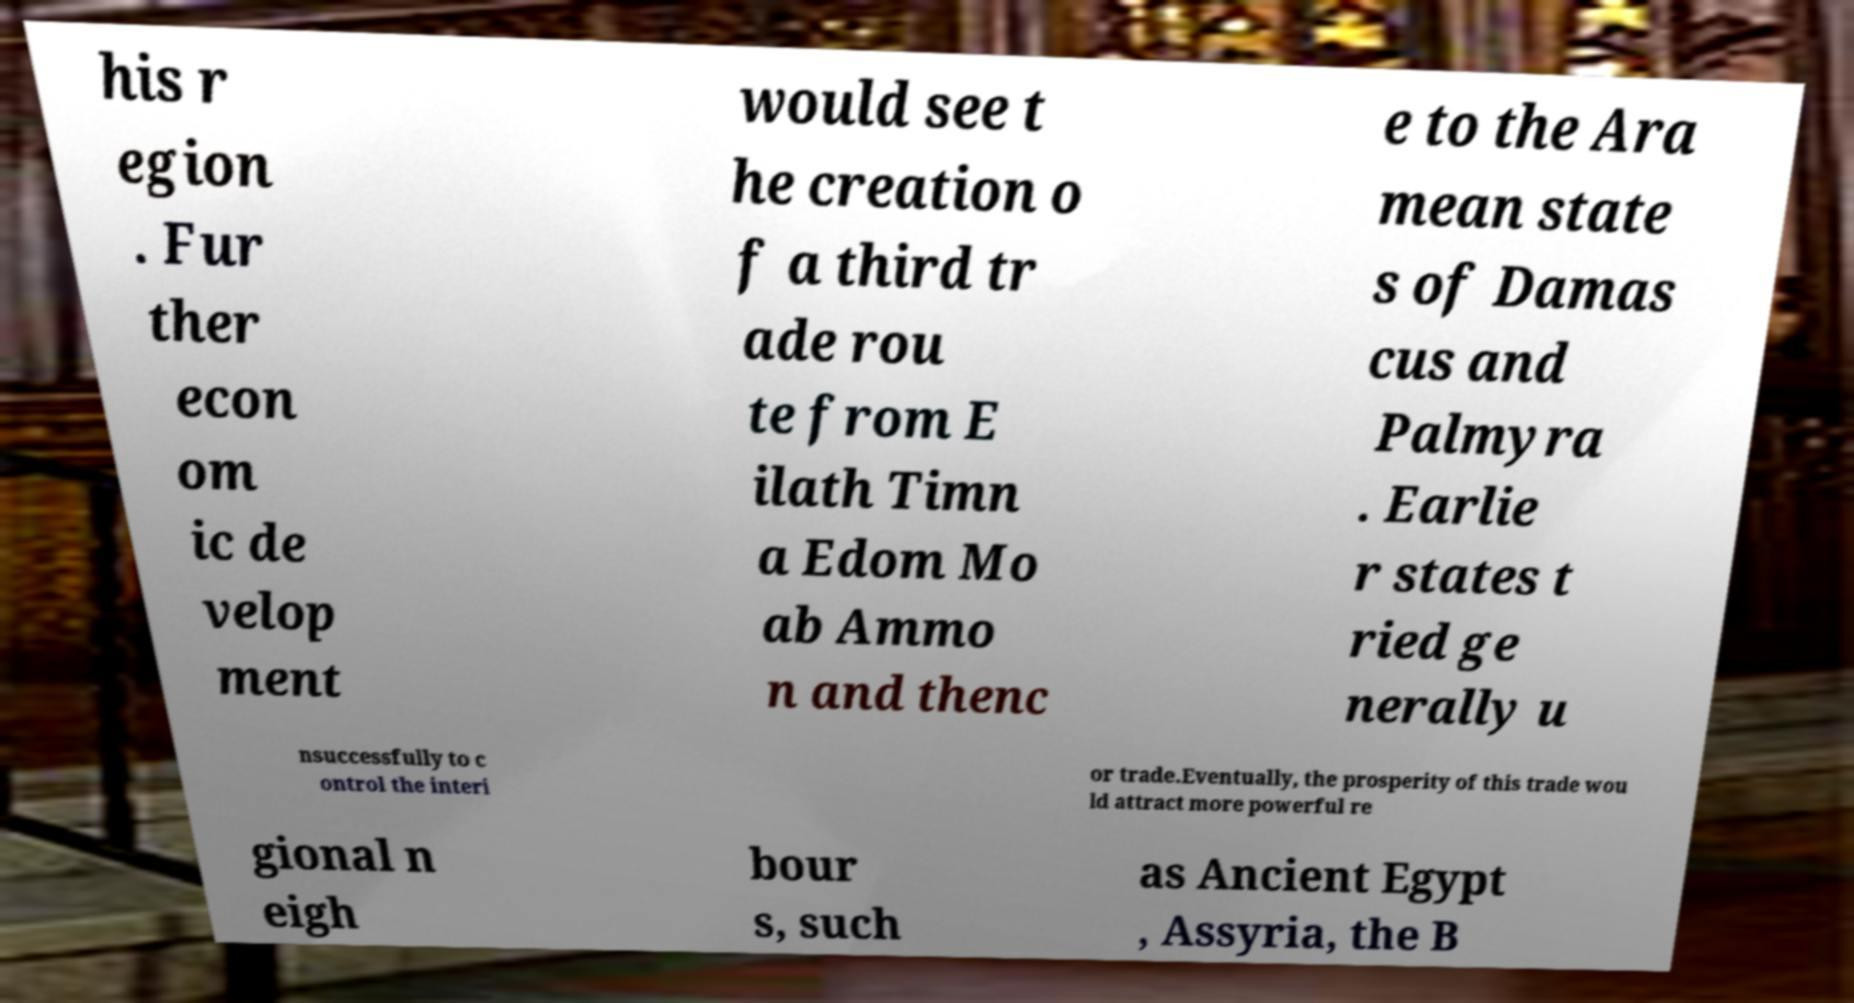Can you accurately transcribe the text from the provided image for me? his r egion . Fur ther econ om ic de velop ment would see t he creation o f a third tr ade rou te from E ilath Timn a Edom Mo ab Ammo n and thenc e to the Ara mean state s of Damas cus and Palmyra . Earlie r states t ried ge nerally u nsuccessfully to c ontrol the interi or trade.Eventually, the prosperity of this trade wou ld attract more powerful re gional n eigh bour s, such as Ancient Egypt , Assyria, the B 